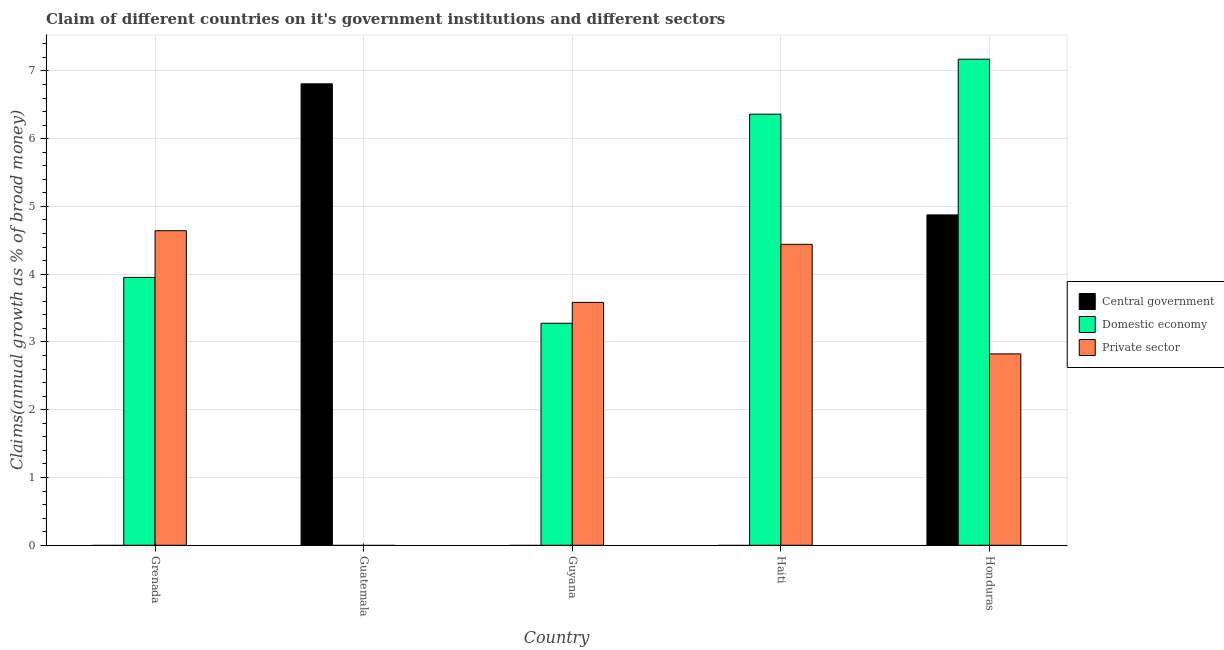How many different coloured bars are there?
Your answer should be compact. 3. How many bars are there on the 3rd tick from the right?
Make the answer very short. 2. What is the label of the 5th group of bars from the left?
Your answer should be compact. Honduras. In how many cases, is the number of bars for a given country not equal to the number of legend labels?
Provide a succinct answer. 4. What is the percentage of claim on the domestic economy in Honduras?
Give a very brief answer. 7.17. Across all countries, what is the maximum percentage of claim on the domestic economy?
Make the answer very short. 7.17. Across all countries, what is the minimum percentage of claim on the private sector?
Provide a short and direct response. 0. In which country was the percentage of claim on the private sector maximum?
Your answer should be very brief. Grenada. What is the total percentage of claim on the private sector in the graph?
Your answer should be compact. 15.49. What is the difference between the percentage of claim on the private sector in Grenada and that in Guyana?
Give a very brief answer. 1.06. What is the difference between the percentage of claim on the private sector in Haiti and the percentage of claim on the domestic economy in Guatemala?
Keep it short and to the point. 4.44. What is the average percentage of claim on the private sector per country?
Give a very brief answer. 3.1. What is the difference between the percentage of claim on the central government and percentage of claim on the domestic economy in Honduras?
Ensure brevity in your answer.  -2.3. What is the ratio of the percentage of claim on the private sector in Grenada to that in Guyana?
Provide a short and direct response. 1.3. Is the percentage of claim on the private sector in Guyana less than that in Honduras?
Make the answer very short. No. What is the difference between the highest and the second highest percentage of claim on the domestic economy?
Keep it short and to the point. 0.81. What is the difference between the highest and the lowest percentage of claim on the private sector?
Your response must be concise. 4.64. In how many countries, is the percentage of claim on the private sector greater than the average percentage of claim on the private sector taken over all countries?
Make the answer very short. 3. Is it the case that in every country, the sum of the percentage of claim on the central government and percentage of claim on the domestic economy is greater than the percentage of claim on the private sector?
Offer a terse response. No. How many bars are there?
Your answer should be compact. 10. Are all the bars in the graph horizontal?
Provide a short and direct response. No. Does the graph contain any zero values?
Provide a succinct answer. Yes. Does the graph contain grids?
Your answer should be compact. Yes. Where does the legend appear in the graph?
Make the answer very short. Center right. How are the legend labels stacked?
Give a very brief answer. Vertical. What is the title of the graph?
Your response must be concise. Claim of different countries on it's government institutions and different sectors. What is the label or title of the X-axis?
Provide a short and direct response. Country. What is the label or title of the Y-axis?
Offer a terse response. Claims(annual growth as % of broad money). What is the Claims(annual growth as % of broad money) of Central government in Grenada?
Make the answer very short. 0. What is the Claims(annual growth as % of broad money) in Domestic economy in Grenada?
Your answer should be compact. 3.95. What is the Claims(annual growth as % of broad money) of Private sector in Grenada?
Make the answer very short. 4.64. What is the Claims(annual growth as % of broad money) of Central government in Guatemala?
Provide a succinct answer. 6.81. What is the Claims(annual growth as % of broad money) of Domestic economy in Guyana?
Provide a succinct answer. 3.28. What is the Claims(annual growth as % of broad money) in Private sector in Guyana?
Your response must be concise. 3.58. What is the Claims(annual growth as % of broad money) in Central government in Haiti?
Keep it short and to the point. 0. What is the Claims(annual growth as % of broad money) of Domestic economy in Haiti?
Make the answer very short. 6.36. What is the Claims(annual growth as % of broad money) in Private sector in Haiti?
Your answer should be very brief. 4.44. What is the Claims(annual growth as % of broad money) in Central government in Honduras?
Ensure brevity in your answer.  4.88. What is the Claims(annual growth as % of broad money) in Domestic economy in Honduras?
Provide a short and direct response. 7.17. What is the Claims(annual growth as % of broad money) in Private sector in Honduras?
Provide a succinct answer. 2.82. Across all countries, what is the maximum Claims(annual growth as % of broad money) of Central government?
Offer a terse response. 6.81. Across all countries, what is the maximum Claims(annual growth as % of broad money) in Domestic economy?
Your response must be concise. 7.17. Across all countries, what is the maximum Claims(annual growth as % of broad money) in Private sector?
Offer a terse response. 4.64. Across all countries, what is the minimum Claims(annual growth as % of broad money) of Central government?
Provide a succinct answer. 0. Across all countries, what is the minimum Claims(annual growth as % of broad money) of Private sector?
Make the answer very short. 0. What is the total Claims(annual growth as % of broad money) in Central government in the graph?
Keep it short and to the point. 11.68. What is the total Claims(annual growth as % of broad money) in Domestic economy in the graph?
Ensure brevity in your answer.  20.76. What is the total Claims(annual growth as % of broad money) in Private sector in the graph?
Your answer should be compact. 15.49. What is the difference between the Claims(annual growth as % of broad money) in Domestic economy in Grenada and that in Guyana?
Your answer should be compact. 0.68. What is the difference between the Claims(annual growth as % of broad money) in Private sector in Grenada and that in Guyana?
Your answer should be compact. 1.06. What is the difference between the Claims(annual growth as % of broad money) of Domestic economy in Grenada and that in Haiti?
Your answer should be very brief. -2.41. What is the difference between the Claims(annual growth as % of broad money) in Private sector in Grenada and that in Haiti?
Your answer should be very brief. 0.2. What is the difference between the Claims(annual growth as % of broad money) of Domestic economy in Grenada and that in Honduras?
Provide a succinct answer. -3.22. What is the difference between the Claims(annual growth as % of broad money) of Private sector in Grenada and that in Honduras?
Keep it short and to the point. 1.82. What is the difference between the Claims(annual growth as % of broad money) of Central government in Guatemala and that in Honduras?
Offer a terse response. 1.93. What is the difference between the Claims(annual growth as % of broad money) of Domestic economy in Guyana and that in Haiti?
Offer a terse response. -3.09. What is the difference between the Claims(annual growth as % of broad money) of Private sector in Guyana and that in Haiti?
Provide a succinct answer. -0.86. What is the difference between the Claims(annual growth as % of broad money) of Domestic economy in Guyana and that in Honduras?
Make the answer very short. -3.9. What is the difference between the Claims(annual growth as % of broad money) in Private sector in Guyana and that in Honduras?
Make the answer very short. 0.76. What is the difference between the Claims(annual growth as % of broad money) in Domestic economy in Haiti and that in Honduras?
Keep it short and to the point. -0.81. What is the difference between the Claims(annual growth as % of broad money) in Private sector in Haiti and that in Honduras?
Make the answer very short. 1.62. What is the difference between the Claims(annual growth as % of broad money) in Domestic economy in Grenada and the Claims(annual growth as % of broad money) in Private sector in Guyana?
Ensure brevity in your answer.  0.37. What is the difference between the Claims(annual growth as % of broad money) in Domestic economy in Grenada and the Claims(annual growth as % of broad money) in Private sector in Haiti?
Your answer should be compact. -0.49. What is the difference between the Claims(annual growth as % of broad money) of Domestic economy in Grenada and the Claims(annual growth as % of broad money) of Private sector in Honduras?
Ensure brevity in your answer.  1.13. What is the difference between the Claims(annual growth as % of broad money) in Central government in Guatemala and the Claims(annual growth as % of broad money) in Domestic economy in Guyana?
Offer a terse response. 3.53. What is the difference between the Claims(annual growth as % of broad money) of Central government in Guatemala and the Claims(annual growth as % of broad money) of Private sector in Guyana?
Offer a very short reply. 3.23. What is the difference between the Claims(annual growth as % of broad money) of Central government in Guatemala and the Claims(annual growth as % of broad money) of Domestic economy in Haiti?
Your answer should be very brief. 0.45. What is the difference between the Claims(annual growth as % of broad money) in Central government in Guatemala and the Claims(annual growth as % of broad money) in Private sector in Haiti?
Give a very brief answer. 2.37. What is the difference between the Claims(annual growth as % of broad money) of Central government in Guatemala and the Claims(annual growth as % of broad money) of Domestic economy in Honduras?
Ensure brevity in your answer.  -0.36. What is the difference between the Claims(annual growth as % of broad money) of Central government in Guatemala and the Claims(annual growth as % of broad money) of Private sector in Honduras?
Offer a very short reply. 3.99. What is the difference between the Claims(annual growth as % of broad money) of Domestic economy in Guyana and the Claims(annual growth as % of broad money) of Private sector in Haiti?
Offer a very short reply. -1.16. What is the difference between the Claims(annual growth as % of broad money) in Domestic economy in Guyana and the Claims(annual growth as % of broad money) in Private sector in Honduras?
Your answer should be very brief. 0.45. What is the difference between the Claims(annual growth as % of broad money) of Domestic economy in Haiti and the Claims(annual growth as % of broad money) of Private sector in Honduras?
Your answer should be compact. 3.54. What is the average Claims(annual growth as % of broad money) of Central government per country?
Keep it short and to the point. 2.34. What is the average Claims(annual growth as % of broad money) of Domestic economy per country?
Offer a terse response. 4.15. What is the average Claims(annual growth as % of broad money) in Private sector per country?
Your answer should be compact. 3.1. What is the difference between the Claims(annual growth as % of broad money) in Domestic economy and Claims(annual growth as % of broad money) in Private sector in Grenada?
Make the answer very short. -0.69. What is the difference between the Claims(annual growth as % of broad money) of Domestic economy and Claims(annual growth as % of broad money) of Private sector in Guyana?
Your response must be concise. -0.31. What is the difference between the Claims(annual growth as % of broad money) of Domestic economy and Claims(annual growth as % of broad money) of Private sector in Haiti?
Offer a terse response. 1.92. What is the difference between the Claims(annual growth as % of broad money) of Central government and Claims(annual growth as % of broad money) of Domestic economy in Honduras?
Give a very brief answer. -2.3. What is the difference between the Claims(annual growth as % of broad money) in Central government and Claims(annual growth as % of broad money) in Private sector in Honduras?
Your answer should be compact. 2.05. What is the difference between the Claims(annual growth as % of broad money) of Domestic economy and Claims(annual growth as % of broad money) of Private sector in Honduras?
Keep it short and to the point. 4.35. What is the ratio of the Claims(annual growth as % of broad money) of Domestic economy in Grenada to that in Guyana?
Your response must be concise. 1.21. What is the ratio of the Claims(annual growth as % of broad money) of Private sector in Grenada to that in Guyana?
Your response must be concise. 1.3. What is the ratio of the Claims(annual growth as % of broad money) of Domestic economy in Grenada to that in Haiti?
Offer a very short reply. 0.62. What is the ratio of the Claims(annual growth as % of broad money) of Private sector in Grenada to that in Haiti?
Keep it short and to the point. 1.05. What is the ratio of the Claims(annual growth as % of broad money) in Domestic economy in Grenada to that in Honduras?
Offer a terse response. 0.55. What is the ratio of the Claims(annual growth as % of broad money) in Private sector in Grenada to that in Honduras?
Offer a very short reply. 1.64. What is the ratio of the Claims(annual growth as % of broad money) of Central government in Guatemala to that in Honduras?
Your response must be concise. 1.4. What is the ratio of the Claims(annual growth as % of broad money) in Domestic economy in Guyana to that in Haiti?
Provide a succinct answer. 0.52. What is the ratio of the Claims(annual growth as % of broad money) of Private sector in Guyana to that in Haiti?
Offer a terse response. 0.81. What is the ratio of the Claims(annual growth as % of broad money) of Domestic economy in Guyana to that in Honduras?
Keep it short and to the point. 0.46. What is the ratio of the Claims(annual growth as % of broad money) in Private sector in Guyana to that in Honduras?
Ensure brevity in your answer.  1.27. What is the ratio of the Claims(annual growth as % of broad money) of Domestic economy in Haiti to that in Honduras?
Provide a short and direct response. 0.89. What is the ratio of the Claims(annual growth as % of broad money) in Private sector in Haiti to that in Honduras?
Make the answer very short. 1.57. What is the difference between the highest and the second highest Claims(annual growth as % of broad money) of Domestic economy?
Your response must be concise. 0.81. What is the difference between the highest and the second highest Claims(annual growth as % of broad money) of Private sector?
Your answer should be very brief. 0.2. What is the difference between the highest and the lowest Claims(annual growth as % of broad money) in Central government?
Your answer should be very brief. 6.81. What is the difference between the highest and the lowest Claims(annual growth as % of broad money) in Domestic economy?
Offer a terse response. 7.17. What is the difference between the highest and the lowest Claims(annual growth as % of broad money) in Private sector?
Make the answer very short. 4.64. 